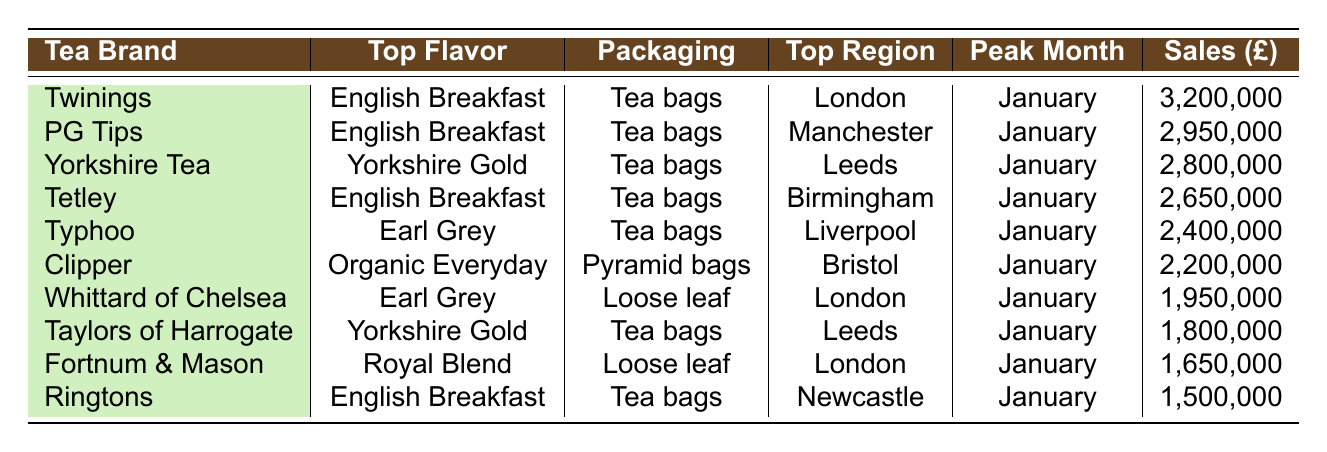What is the top-selling tea brand? Looking at the sales figures, Twinings has the highest sales figure of £3,200,000.
Answer: Twinings Which tea brand is associated with Earl Grey flavor? Typhoo and Whittard of Chelsea are both associated with Earl Grey flavor according to the table.
Answer: Typhoo and Whittard of Chelsea What is the peak month for Yorkshire Tea? The peak month for Yorkshire Tea is January, as it has the highest sales figure listed for that month.
Answer: January How many tea brands have sales figures above £2,500,000? The tea brands that have sales figures above £2,500,000 are Twinings, PG Tips, Yorkshire Tea, Tetley, and Typhoo. There are a total of 5 brands.
Answer: 5 Which tea brand has the lowest sales figure and what is that figure? Ringtons has the lowest sales figure of £1,500,000.
Answer: £1,500,000 What is the total sales figure for all tea brands combined in January? Adding the sales figures in January: 3,200,000 (Twinings) + 2,950,000 (PG Tips) + 2,800,000 (Yorkshire Tea) + 2,650,000 (Tetley) + 2,400,000 (Typhoo) + 2,200,000 (Clipper) + 1,950,000 (Whittard of Chelsea) + 1,800,000 (Taylors of Harrogate) + 1,650,000 (Fortnum & Mason) + 1,500,000 (Ringtons) equals 24,100,000.
Answer: £24,100,000 Are all tea brands sold exclusively as tea bags? No, there are different packaging types, including loose leaf, pyramid bags, and instant tea.
Answer: No Which region has the highest sales for tea brands? The highest sales for tea brands come from London, as Twinings and Whittard of Chelsea, both from London, have significant sales figures.
Answer: London What is the average sales figure for tea brands listed in the table? To find the average, sum up all sales figures and divide by the number of brands: (3,200,000 + 2,950,000 + 2,800,000 + 2,650,000 + 2,400,000 + 2,200,000 + 1,950,000 + 1,800,000 + 1,650,000 + 1,500,000) = 24,100,000. There are 10 brands, so the average is £2,410,000.
Answer: £2,410,000 Which tea brand has a peak sales month in December? The data does not specify which brands have peak sales in December; therefore, we cannot determine if any brand has a peak sales month in December.
Answer: Cannot be determined 